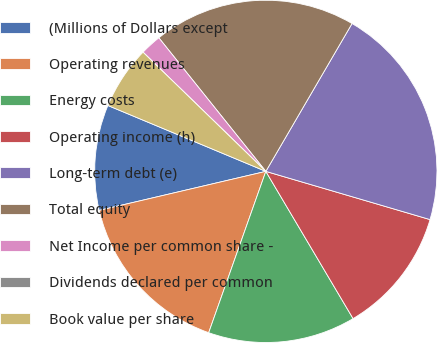Convert chart. <chart><loc_0><loc_0><loc_500><loc_500><pie_chart><fcel>(Millions of Dollars except<fcel>Operating revenues<fcel>Energy costs<fcel>Operating income (h)<fcel>Long-term debt (e)<fcel>Total equity<fcel>Net Income per common share -<fcel>Dividends declared per common<fcel>Book value per share<nl><fcel>9.95%<fcel>15.92%<fcel>13.93%<fcel>11.94%<fcel>21.14%<fcel>19.15%<fcel>1.99%<fcel>0.0%<fcel>5.97%<nl></chart> 